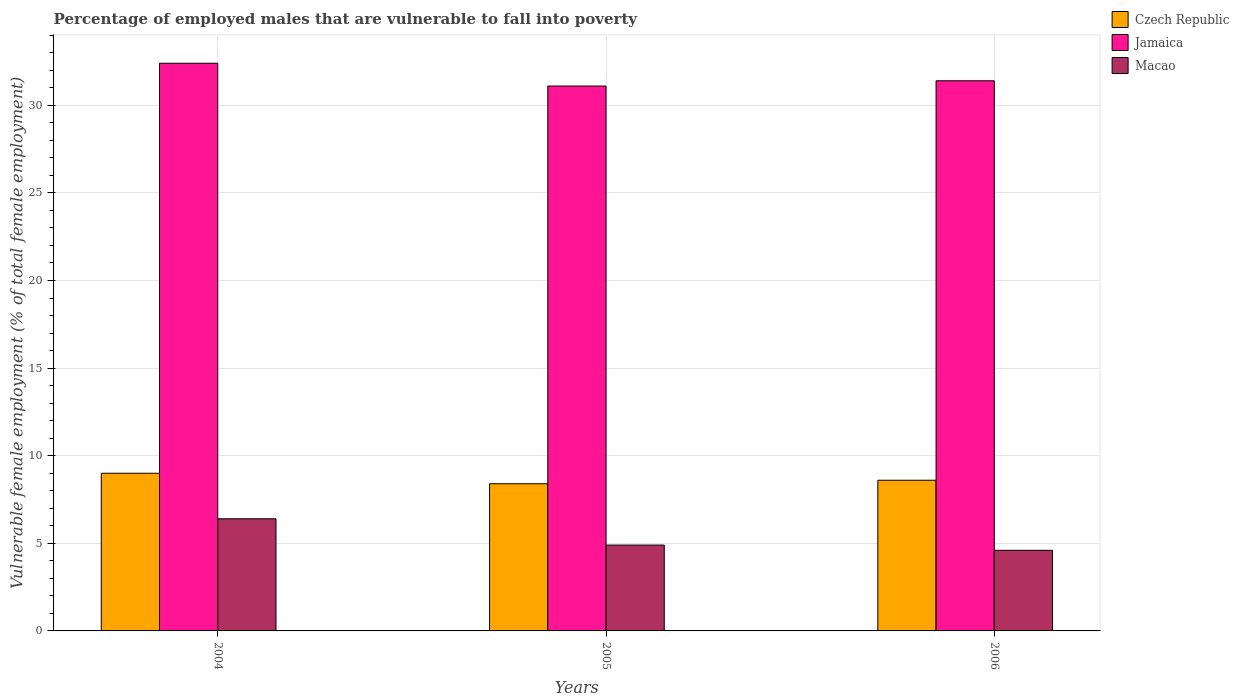How many groups of bars are there?
Your answer should be very brief. 3. Are the number of bars on each tick of the X-axis equal?
Provide a succinct answer. Yes. In how many cases, is the number of bars for a given year not equal to the number of legend labels?
Your answer should be very brief. 0. What is the percentage of employed males who are vulnerable to fall into poverty in Macao in 2005?
Keep it short and to the point. 4.9. Across all years, what is the maximum percentage of employed males who are vulnerable to fall into poverty in Macao?
Provide a short and direct response. 6.4. Across all years, what is the minimum percentage of employed males who are vulnerable to fall into poverty in Macao?
Keep it short and to the point. 4.6. In which year was the percentage of employed males who are vulnerable to fall into poverty in Jamaica minimum?
Ensure brevity in your answer.  2005. What is the total percentage of employed males who are vulnerable to fall into poverty in Jamaica in the graph?
Offer a terse response. 94.9. What is the difference between the percentage of employed males who are vulnerable to fall into poverty in Jamaica in 2005 and that in 2006?
Provide a succinct answer. -0.3. What is the difference between the percentage of employed males who are vulnerable to fall into poverty in Macao in 2005 and the percentage of employed males who are vulnerable to fall into poverty in Czech Republic in 2004?
Your response must be concise. -4.1. What is the average percentage of employed males who are vulnerable to fall into poverty in Czech Republic per year?
Give a very brief answer. 8.67. In the year 2006, what is the difference between the percentage of employed males who are vulnerable to fall into poverty in Macao and percentage of employed males who are vulnerable to fall into poverty in Jamaica?
Offer a terse response. -26.8. What is the ratio of the percentage of employed males who are vulnerable to fall into poverty in Czech Republic in 2005 to that in 2006?
Make the answer very short. 0.98. What is the difference between the highest and the second highest percentage of employed males who are vulnerable to fall into poverty in Czech Republic?
Offer a terse response. 0.4. What is the difference between the highest and the lowest percentage of employed males who are vulnerable to fall into poverty in Czech Republic?
Offer a terse response. 0.6. In how many years, is the percentage of employed males who are vulnerable to fall into poverty in Macao greater than the average percentage of employed males who are vulnerable to fall into poverty in Macao taken over all years?
Make the answer very short. 1. Is the sum of the percentage of employed males who are vulnerable to fall into poverty in Jamaica in 2004 and 2005 greater than the maximum percentage of employed males who are vulnerable to fall into poverty in Macao across all years?
Give a very brief answer. Yes. What does the 3rd bar from the left in 2005 represents?
Ensure brevity in your answer.  Macao. What does the 3rd bar from the right in 2006 represents?
Your response must be concise. Czech Republic. How many bars are there?
Offer a terse response. 9. How many years are there in the graph?
Offer a terse response. 3. What is the difference between two consecutive major ticks on the Y-axis?
Your answer should be very brief. 5. Are the values on the major ticks of Y-axis written in scientific E-notation?
Your answer should be compact. No. Does the graph contain grids?
Your response must be concise. Yes. How many legend labels are there?
Offer a terse response. 3. How are the legend labels stacked?
Ensure brevity in your answer.  Vertical. What is the title of the graph?
Your answer should be very brief. Percentage of employed males that are vulnerable to fall into poverty. Does "Romania" appear as one of the legend labels in the graph?
Offer a very short reply. No. What is the label or title of the Y-axis?
Provide a succinct answer. Vulnerable female employment (% of total female employment). What is the Vulnerable female employment (% of total female employment) of Czech Republic in 2004?
Make the answer very short. 9. What is the Vulnerable female employment (% of total female employment) in Jamaica in 2004?
Your response must be concise. 32.4. What is the Vulnerable female employment (% of total female employment) of Macao in 2004?
Offer a terse response. 6.4. What is the Vulnerable female employment (% of total female employment) of Czech Republic in 2005?
Offer a very short reply. 8.4. What is the Vulnerable female employment (% of total female employment) in Jamaica in 2005?
Your answer should be very brief. 31.1. What is the Vulnerable female employment (% of total female employment) in Macao in 2005?
Offer a terse response. 4.9. What is the Vulnerable female employment (% of total female employment) in Czech Republic in 2006?
Your response must be concise. 8.6. What is the Vulnerable female employment (% of total female employment) in Jamaica in 2006?
Your answer should be compact. 31.4. What is the Vulnerable female employment (% of total female employment) of Macao in 2006?
Provide a succinct answer. 4.6. Across all years, what is the maximum Vulnerable female employment (% of total female employment) in Jamaica?
Your answer should be compact. 32.4. Across all years, what is the maximum Vulnerable female employment (% of total female employment) in Macao?
Your answer should be compact. 6.4. Across all years, what is the minimum Vulnerable female employment (% of total female employment) of Czech Republic?
Ensure brevity in your answer.  8.4. Across all years, what is the minimum Vulnerable female employment (% of total female employment) in Jamaica?
Offer a terse response. 31.1. Across all years, what is the minimum Vulnerable female employment (% of total female employment) in Macao?
Keep it short and to the point. 4.6. What is the total Vulnerable female employment (% of total female employment) of Czech Republic in the graph?
Provide a succinct answer. 26. What is the total Vulnerable female employment (% of total female employment) of Jamaica in the graph?
Give a very brief answer. 94.9. What is the total Vulnerable female employment (% of total female employment) in Macao in the graph?
Keep it short and to the point. 15.9. What is the difference between the Vulnerable female employment (% of total female employment) of Czech Republic in 2004 and that in 2005?
Your response must be concise. 0.6. What is the difference between the Vulnerable female employment (% of total female employment) of Jamaica in 2004 and that in 2005?
Your response must be concise. 1.3. What is the difference between the Vulnerable female employment (% of total female employment) in Czech Republic in 2004 and that in 2006?
Make the answer very short. 0.4. What is the difference between the Vulnerable female employment (% of total female employment) in Macao in 2004 and that in 2006?
Provide a short and direct response. 1.8. What is the difference between the Vulnerable female employment (% of total female employment) of Czech Republic in 2004 and the Vulnerable female employment (% of total female employment) of Jamaica in 2005?
Your answer should be very brief. -22.1. What is the difference between the Vulnerable female employment (% of total female employment) in Czech Republic in 2004 and the Vulnerable female employment (% of total female employment) in Macao in 2005?
Make the answer very short. 4.1. What is the difference between the Vulnerable female employment (% of total female employment) of Jamaica in 2004 and the Vulnerable female employment (% of total female employment) of Macao in 2005?
Keep it short and to the point. 27.5. What is the difference between the Vulnerable female employment (% of total female employment) of Czech Republic in 2004 and the Vulnerable female employment (% of total female employment) of Jamaica in 2006?
Your answer should be compact. -22.4. What is the difference between the Vulnerable female employment (% of total female employment) of Jamaica in 2004 and the Vulnerable female employment (% of total female employment) of Macao in 2006?
Make the answer very short. 27.8. What is the difference between the Vulnerable female employment (% of total female employment) in Czech Republic in 2005 and the Vulnerable female employment (% of total female employment) in Macao in 2006?
Your answer should be compact. 3.8. What is the average Vulnerable female employment (% of total female employment) of Czech Republic per year?
Your answer should be very brief. 8.67. What is the average Vulnerable female employment (% of total female employment) of Jamaica per year?
Make the answer very short. 31.63. In the year 2004, what is the difference between the Vulnerable female employment (% of total female employment) in Czech Republic and Vulnerable female employment (% of total female employment) in Jamaica?
Your answer should be very brief. -23.4. In the year 2004, what is the difference between the Vulnerable female employment (% of total female employment) in Czech Republic and Vulnerable female employment (% of total female employment) in Macao?
Offer a very short reply. 2.6. In the year 2004, what is the difference between the Vulnerable female employment (% of total female employment) in Jamaica and Vulnerable female employment (% of total female employment) in Macao?
Provide a succinct answer. 26. In the year 2005, what is the difference between the Vulnerable female employment (% of total female employment) of Czech Republic and Vulnerable female employment (% of total female employment) of Jamaica?
Provide a succinct answer. -22.7. In the year 2005, what is the difference between the Vulnerable female employment (% of total female employment) of Czech Republic and Vulnerable female employment (% of total female employment) of Macao?
Provide a short and direct response. 3.5. In the year 2005, what is the difference between the Vulnerable female employment (% of total female employment) of Jamaica and Vulnerable female employment (% of total female employment) of Macao?
Give a very brief answer. 26.2. In the year 2006, what is the difference between the Vulnerable female employment (% of total female employment) in Czech Republic and Vulnerable female employment (% of total female employment) in Jamaica?
Ensure brevity in your answer.  -22.8. In the year 2006, what is the difference between the Vulnerable female employment (% of total female employment) of Czech Republic and Vulnerable female employment (% of total female employment) of Macao?
Give a very brief answer. 4. In the year 2006, what is the difference between the Vulnerable female employment (% of total female employment) of Jamaica and Vulnerable female employment (% of total female employment) of Macao?
Offer a very short reply. 26.8. What is the ratio of the Vulnerable female employment (% of total female employment) of Czech Republic in 2004 to that in 2005?
Your answer should be very brief. 1.07. What is the ratio of the Vulnerable female employment (% of total female employment) in Jamaica in 2004 to that in 2005?
Your response must be concise. 1.04. What is the ratio of the Vulnerable female employment (% of total female employment) in Macao in 2004 to that in 2005?
Keep it short and to the point. 1.31. What is the ratio of the Vulnerable female employment (% of total female employment) in Czech Republic in 2004 to that in 2006?
Make the answer very short. 1.05. What is the ratio of the Vulnerable female employment (% of total female employment) in Jamaica in 2004 to that in 2006?
Give a very brief answer. 1.03. What is the ratio of the Vulnerable female employment (% of total female employment) of Macao in 2004 to that in 2006?
Provide a short and direct response. 1.39. What is the ratio of the Vulnerable female employment (% of total female employment) in Czech Republic in 2005 to that in 2006?
Your answer should be very brief. 0.98. What is the ratio of the Vulnerable female employment (% of total female employment) in Jamaica in 2005 to that in 2006?
Your answer should be compact. 0.99. What is the ratio of the Vulnerable female employment (% of total female employment) of Macao in 2005 to that in 2006?
Offer a terse response. 1.07. What is the difference between the highest and the second highest Vulnerable female employment (% of total female employment) in Czech Republic?
Your answer should be compact. 0.4. What is the difference between the highest and the second highest Vulnerable female employment (% of total female employment) in Jamaica?
Your answer should be very brief. 1. What is the difference between the highest and the lowest Vulnerable female employment (% of total female employment) of Jamaica?
Your answer should be compact. 1.3. What is the difference between the highest and the lowest Vulnerable female employment (% of total female employment) of Macao?
Your answer should be compact. 1.8. 